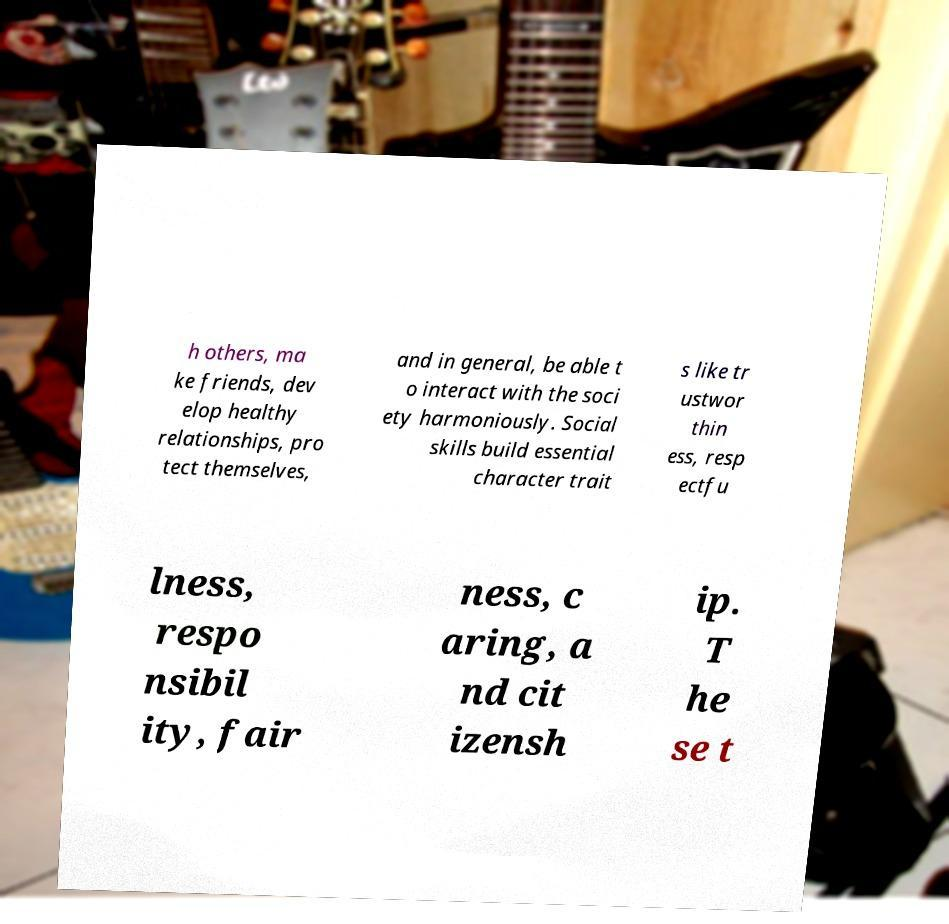Can you accurately transcribe the text from the provided image for me? h others, ma ke friends, dev elop healthy relationships, pro tect themselves, and in general, be able t o interact with the soci ety harmoniously. Social skills build essential character trait s like tr ustwor thin ess, resp ectfu lness, respo nsibil ity, fair ness, c aring, a nd cit izensh ip. T he se t 